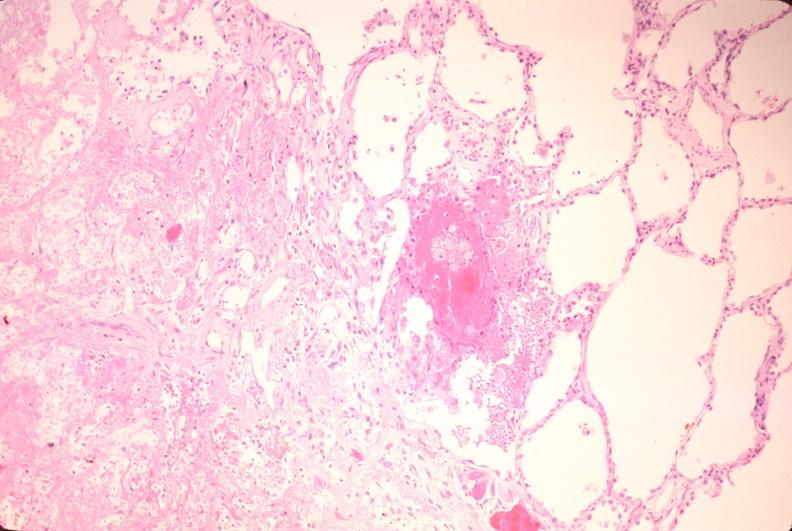does this image show lung, infarct, acute and organized?
Answer the question using a single word or phrase. Yes 